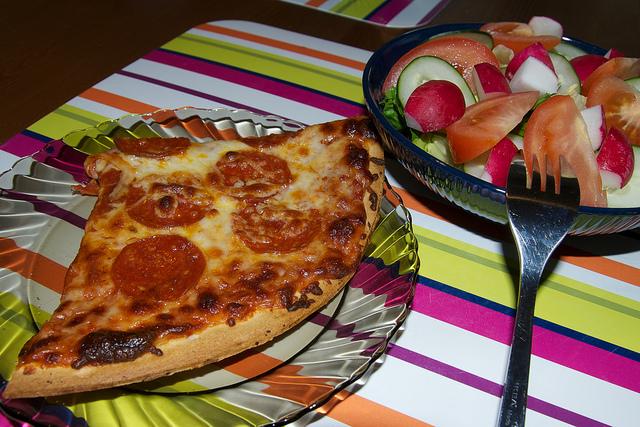What topping is on the pizza?
Be succinct. Pepperoni. What is on the clear plate?
Write a very short answer. Pizza. What is the red and white vegetable?
Keep it brief. Radish. 